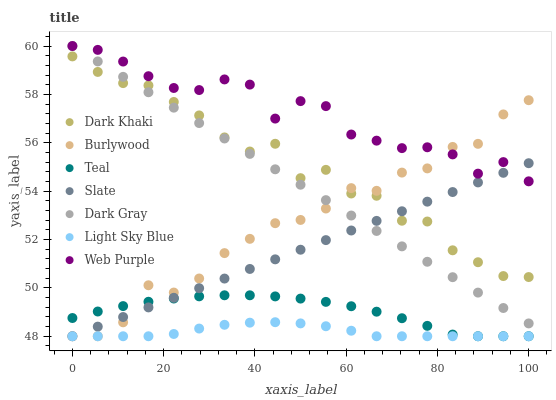Does Light Sky Blue have the minimum area under the curve?
Answer yes or no. Yes. Does Web Purple have the maximum area under the curve?
Answer yes or no. Yes. Does Burlywood have the minimum area under the curve?
Answer yes or no. No. Does Burlywood have the maximum area under the curve?
Answer yes or no. No. Is Slate the smoothest?
Answer yes or no. Yes. Is Dark Khaki the roughest?
Answer yes or no. Yes. Is Burlywood the smoothest?
Answer yes or no. No. Is Burlywood the roughest?
Answer yes or no. No. Does Burlywood have the lowest value?
Answer yes or no. Yes. Does Dark Khaki have the lowest value?
Answer yes or no. No. Does Web Purple have the highest value?
Answer yes or no. Yes. Does Burlywood have the highest value?
Answer yes or no. No. Is Teal less than Dark Gray?
Answer yes or no. Yes. Is Dark Khaki greater than Light Sky Blue?
Answer yes or no. Yes. Does Dark Gray intersect Web Purple?
Answer yes or no. Yes. Is Dark Gray less than Web Purple?
Answer yes or no. No. Is Dark Gray greater than Web Purple?
Answer yes or no. No. Does Teal intersect Dark Gray?
Answer yes or no. No. 